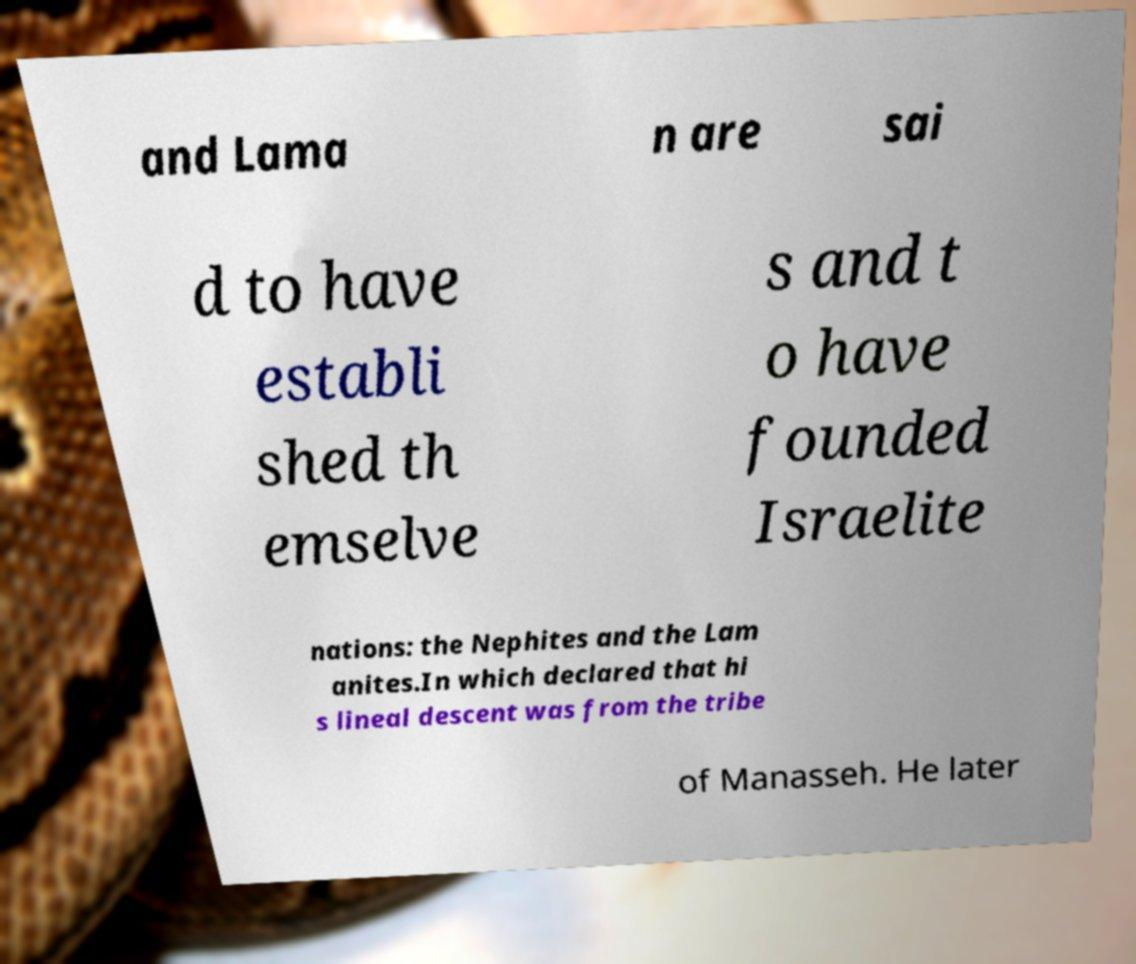For documentation purposes, I need the text within this image transcribed. Could you provide that? and Lama n are sai d to have establi shed th emselve s and t o have founded Israelite nations: the Nephites and the Lam anites.In which declared that hi s lineal descent was from the tribe of Manasseh. He later 